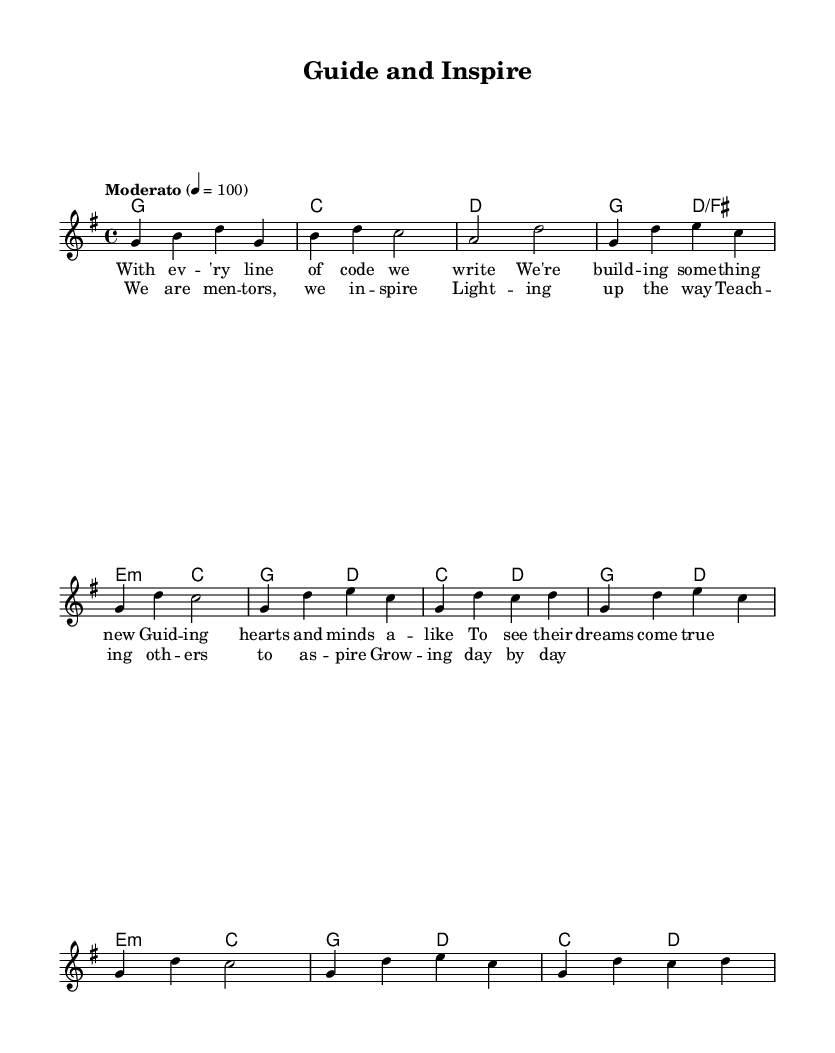What is the key signature of this music? The key signature is indicated as "g" which signifies G major. G major has one sharp, F#.
Answer: G major What is the time signature of this piece? The time signature is shown as "4/4", which means there are four beats in each measure and the quarter note gets one beat.
Answer: 4/4 What is the tempo marking for this music? The tempo of the music is indicated as "Moderato" with a metronome marking of 100 beats per minute.
Answer: Moderato How many measures are in the verse section? The verse consists of two phrases, each containing four measures. Therefore, there are a total of 8 measures in the verse.
Answer: 8 measures What lyrics are associated with the chorus section? The chorus contains the lyrics starting with "We are mentors, we inspire" followed by additional lines. These lyrics reference themes of mentorship and guidance.
Answer: We are mentors, we inspire What harmonic progression is used in the chorus? The harmonic progression for the chorus follows: G major to D major, then E minor to C major, and ends with G major to D major, C major to D major.
Answer: G - D - E minor - C - G - D - C - D What theme is emphasized in the lyrics of the song? The lyrics emphasize the theme of mentorship, describing the act of guiding and inspiring others towards their dreams and aspirations.
Answer: Mentorship 